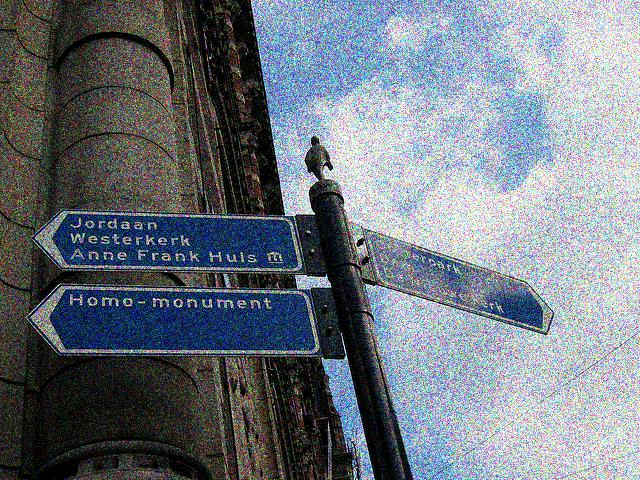What considerations might have gone into the design and placement of these signs? The design of the signs is clear and utilitarian, meant to be easily read by pedestrians and possibly cyclists. The blue color stands out against the urban backdrop, and the white lettering is quite legible. Placement at the street corner, at eye level, and on a post shared with other signs indicates a planned effort to consolidate important directions in one accessible location. Furthermore, the inclusion and prominence of diverse cultural and historic locations reflect the inclusive and commemorative nature of public spaces in this area. 